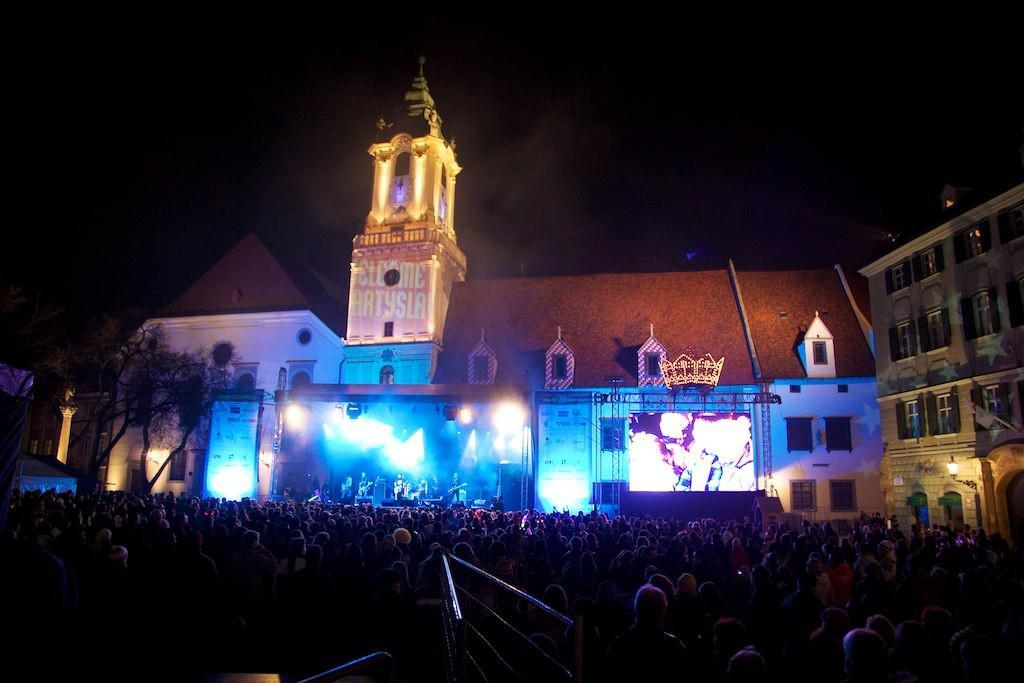What is happening in the image? There is a group of people standing in the image. What can be seen in the background of the image? Trees and buildings are visible in the image. Can you describe the building on the right side of the image? The building on the right side of the image is cream-colored. What is the color of the background in the image? The background of the image appears to be in black color. How many wings can be seen on the cart in the image? There is no cart or wings present in the image. Does the existence of the group of people in the image imply that they have a shared purpose or goal? The image does not provide enough information to determine if the group of people has a shared purpose or goal. 